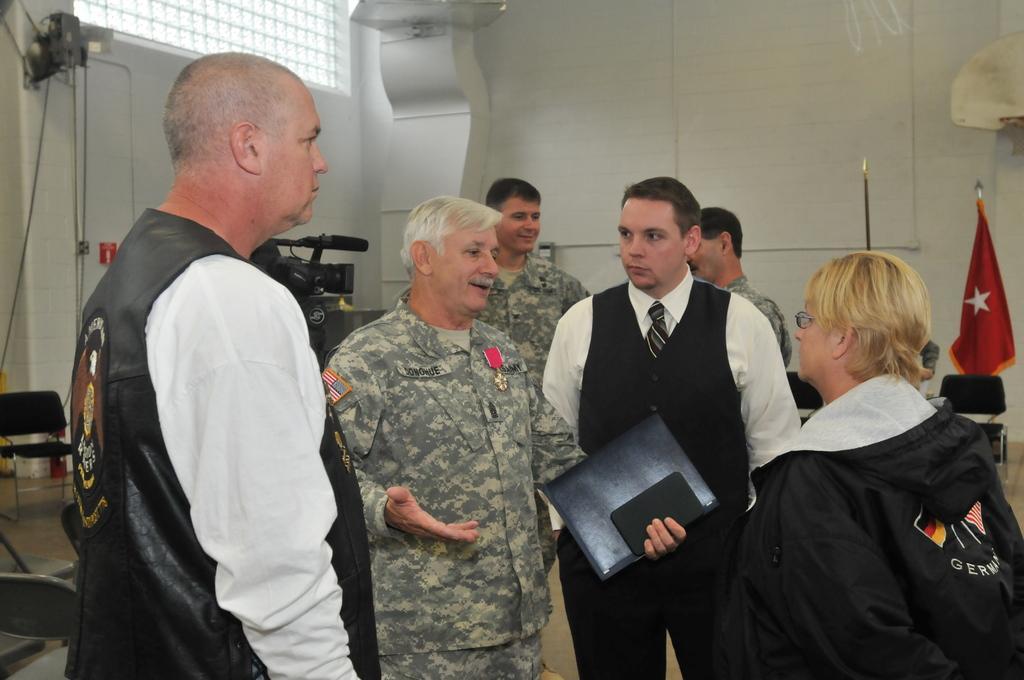Describe this image in one or two sentences. There are people in the foreground area of the image, there are chairs, wires, pillar, window, flag and other objects in the background area. 